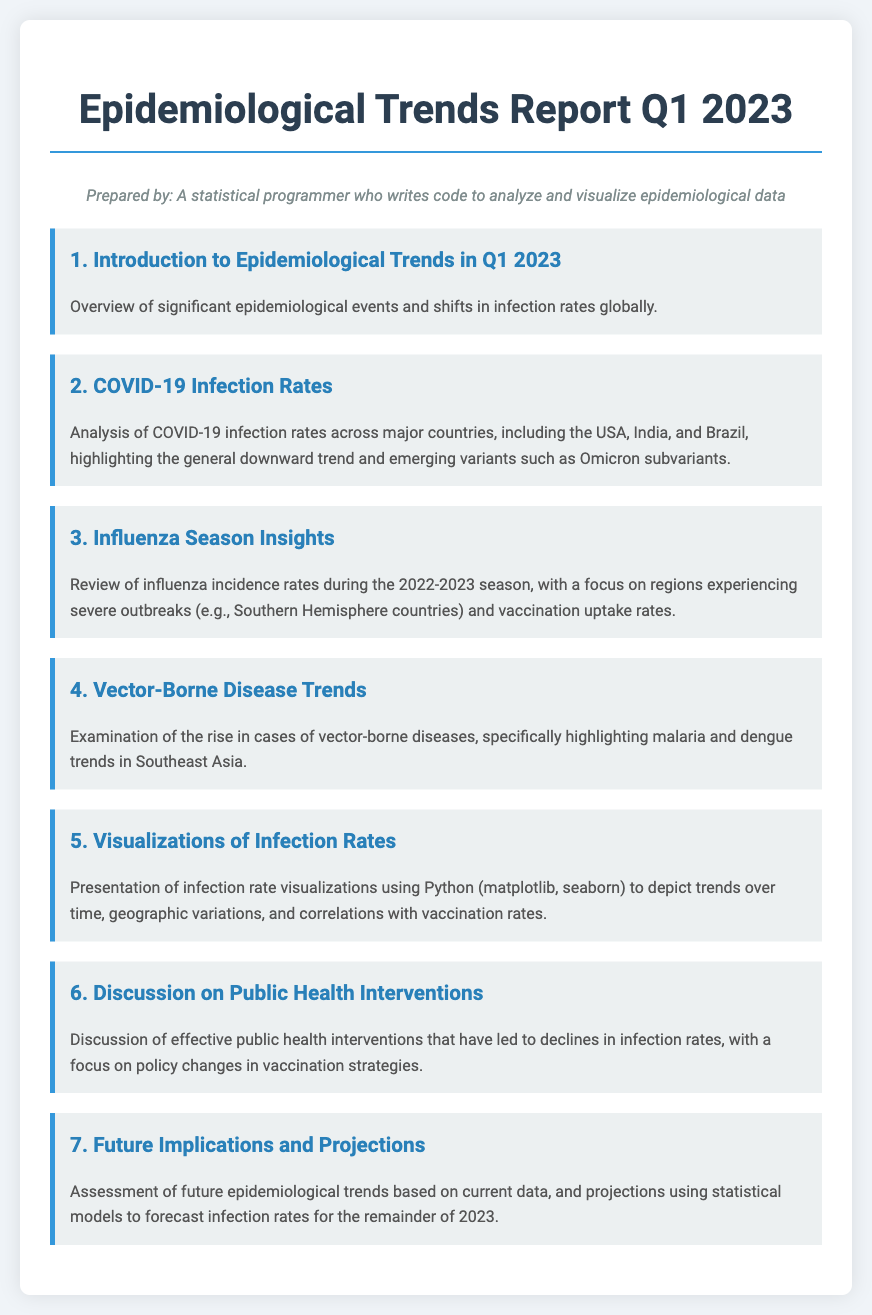What is the title of the report? The title of the report is presented at the top of the document.
Answer: Epidemiological Trends Report Q1 2023 Which country is highlighted for COVID-19 trends? The document specifically mentions three countries for COVID-19 infection rates analysis.
Answer: USA What season's influenza incidence rates are reviewed? The report states the influenza season that is being reviewed.
Answer: 2022-2023 What type of diseases are examined in section 4? The document highlights the diseases being discussed in section 4.
Answer: Vector-borne diseases How many agenda items are presented in this report? The number of agenda items can be counted from the sections listed in the document.
Answer: Seven What has been identified as a factor in the decline of infection rates? The discussion section mentions effective public health strategies.
Answer: Vaccination strategies What tool does the report mention for visualizing infection rates? The report specifies the programming tools used for visualizations.
Answer: Python 